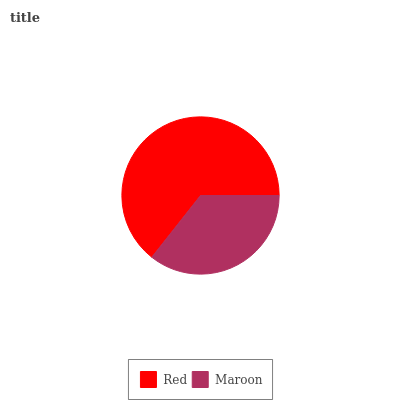Is Maroon the minimum?
Answer yes or no. Yes. Is Red the maximum?
Answer yes or no. Yes. Is Maroon the maximum?
Answer yes or no. No. Is Red greater than Maroon?
Answer yes or no. Yes. Is Maroon less than Red?
Answer yes or no. Yes. Is Maroon greater than Red?
Answer yes or no. No. Is Red less than Maroon?
Answer yes or no. No. Is Red the high median?
Answer yes or no. Yes. Is Maroon the low median?
Answer yes or no. Yes. Is Maroon the high median?
Answer yes or no. No. Is Red the low median?
Answer yes or no. No. 